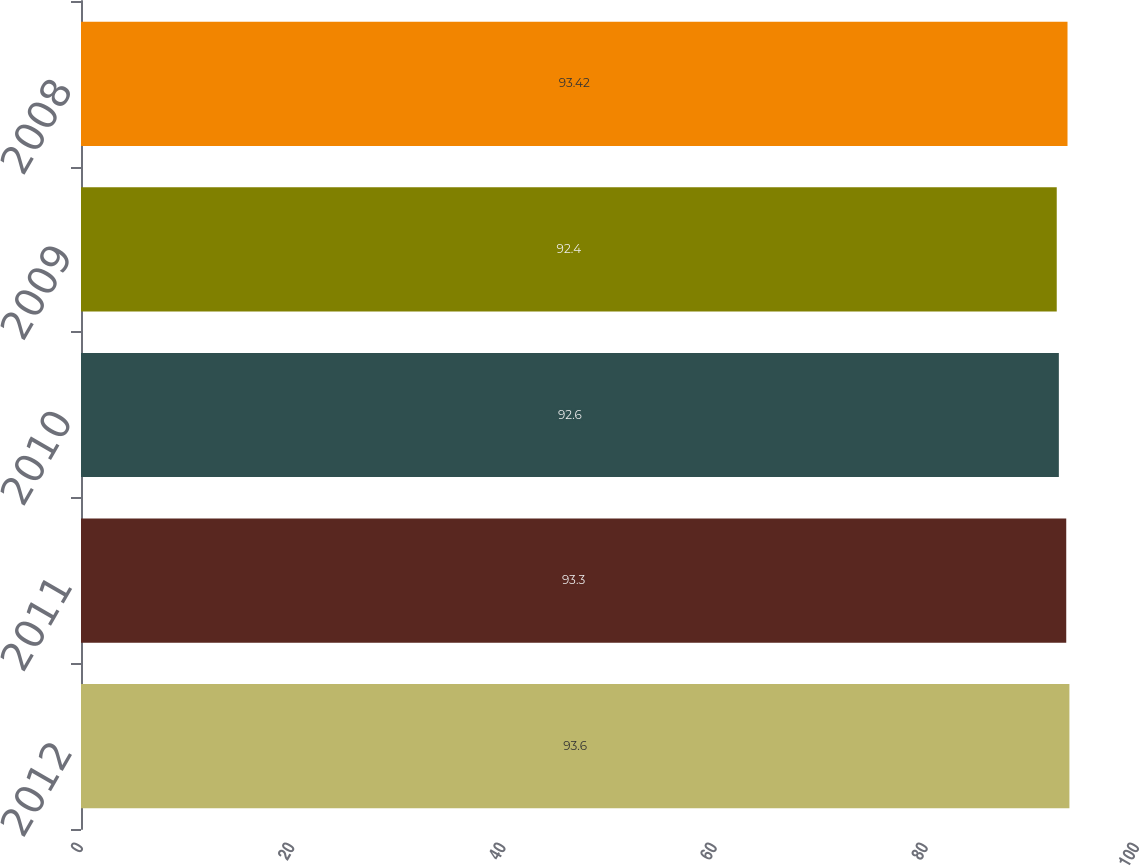Convert chart. <chart><loc_0><loc_0><loc_500><loc_500><bar_chart><fcel>2012<fcel>2011<fcel>2010<fcel>2009<fcel>2008<nl><fcel>93.6<fcel>93.3<fcel>92.6<fcel>92.4<fcel>93.42<nl></chart> 